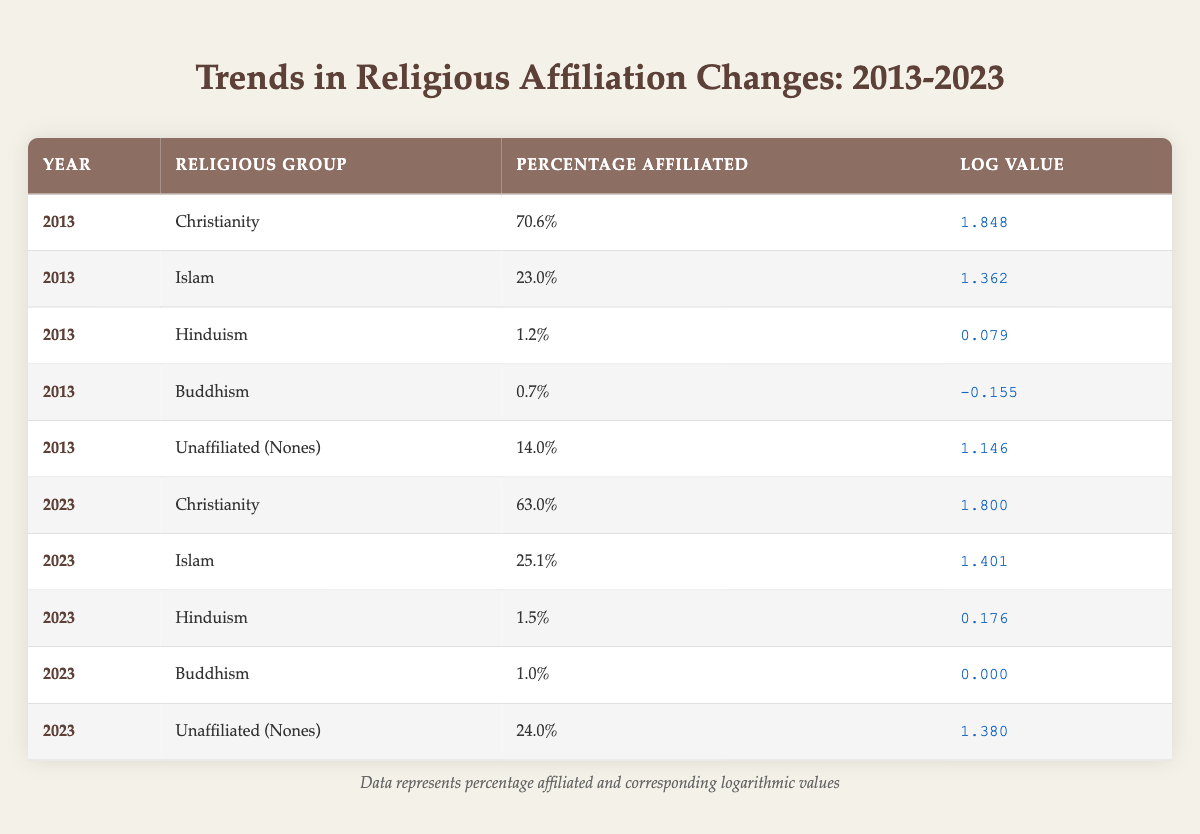What was the percentage of people affiliated with Buddhism in 2013? In the table, the row for Buddhism in 2013 shows a percentage of 0.7%.
Answer: 0.7% How much did the percentage of Unaffiliated (Nones) change from 2013 to 2023? The percentage was 14.0% in 2013 and increased to 24.0% in 2023. The change is calculated as 24.0% - 14.0% = 10.0%.
Answer: 10.0% Was there an increase in the percentage of Muslims from 2013 to 2023? In 2013, the percentage of Muslims was 23.0% and in 2023 it rose to 25.1%. Since 25.1% is greater than 23.0%, this indicates an increase.
Answer: Yes What is the logarithmic value for Hinduism in 2023? The row for Hinduism in 2023 shows a logarithmic value of 0.176.
Answer: 0.176 Which religious group had the highest percentage affiliated in 2013, and what was that percentage? The table indicates that Christianity had the highest percentage affiliated at 70.6% in 2013.
Answer: Christianity, 70.6% What was the average percentage of affiliated individuals across all religious groups in 2023? The percentages in 2023 are: Christianity 63.0%, Islam 25.1%, Hinduism 1.5%, Buddhism 1.0%, and Unaffiliated (Nones) 24.0%. The sum of these percentages is 114.6%, and dividing by 5 gives an average of 22.92%.
Answer: 22.92% Did the percentage of Christianity decrease from 2013 to 2023? In 2013, the percentage was 70.6%, and in 2023 it dropped to 63.0%. Since 63.0% is less than 70.6%, this confirms a decrease.
Answer: Yes Which religious group saw the smallest change in percentage from 2013 to 2023? Comparing the changes, Hinduism went from 1.2% to 1.5%, which is a change of 0.3%. Buddhism went from 0.7% to 1.0%, which is a change of 0.3% as well. Both experienced the smallest change of 0.3%.
Answer: Hinduism and Buddhism, 0.3% change 